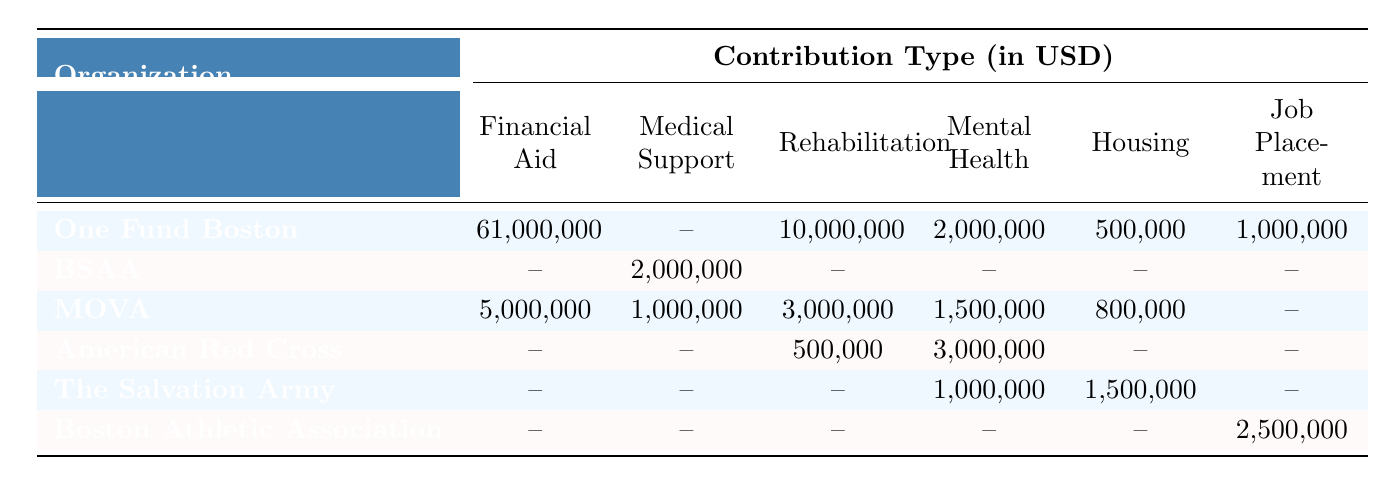What was the highest financial aid amount provided by an organization? The highest financial aid amount is 61,000,000 provided by One Fund Boston.
Answer: 61,000,000 Which organization contributed medical support? The organizations that contributed medical support are Boston Survivors Accessibility Alliance and Massachusetts Office for Victim Assistance.
Answer: BSAA and MOVA Did The Salvation Army provide any financial aid? The Salvation Army did not provide any financial aid as indicated by the value in that column being "--".
Answer: No What is the total amount spent on mental health counseling by all organizations? The total amount spent on mental health counseling is 2,000,000 (One Fund Boston) + 3,000,000 (American Red Cross) + 1,000,000 (The Salvation Army) = 6,000,000.
Answer: 6,000,000 How much did Boston Athletic Association contribute for job placement? Boston Athletic Association contributed 2,500,000 for job placement as indicated by the value in that column.
Answer: 2,500,000 Which organization provided the least amount of contributions overall? The organization that provided the least amount of contributions overall is Boston Survivors Accessibility Alliance, with only 2,000,000 in medical support.
Answer: BSAA Which type of contribution received the most funding? Financial aid received the most funding with a total of 61,000,000 from One Fund Boston.
Answer: Financial aid What is the difference in amounts contributed for rehabilitation services between One Fund Boston and MOVA? One Fund Boston contributed 10,000,000 and MOVA contributed 3,000,000 for rehabilitation. The difference is 10,000,000 - 3,000,000 = 7,000,000.
Answer: 7,000,000 What percentage of the total contributions does the American Red Cross represent? The total contributions are 61,000,000 + 2,000,000 + 5,000,000 + 3,000,000 + 1,500,000 + 2,500,000 = 75,000,000. The American Red Cross contributed 3,500,000. Percentage = (3,500,000 / 75,000,000) * 100 = 4.67%.
Answer: 4.67% Which two organizations provided job placement support? The organizations that provided job placement support are the Boston Athletic Association, which contributed 2,500,000, and no other organization contributed in this category as indicated by the values in the table.
Answer: Boston Athletic Association only 